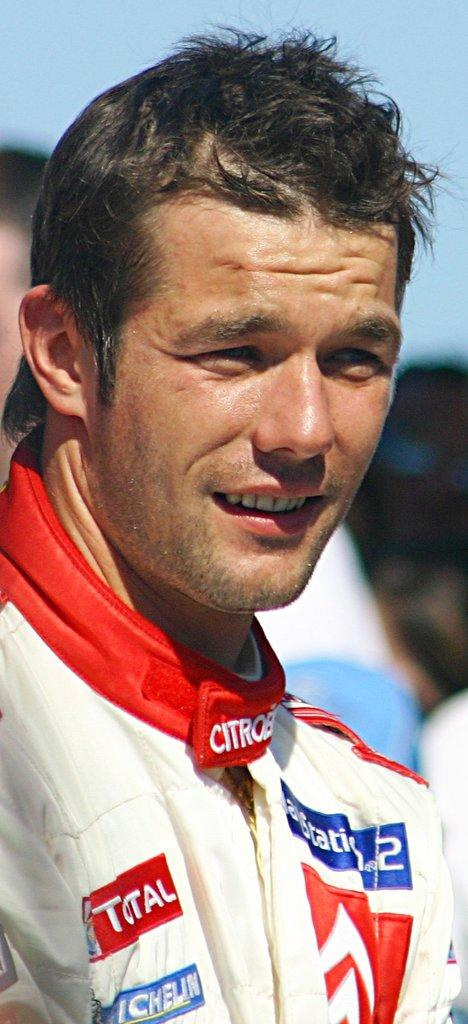Provide a one-sentence caption for the provided image. A man with a red badge on his jacket that includes the word "total" squints in bright sunlight. 